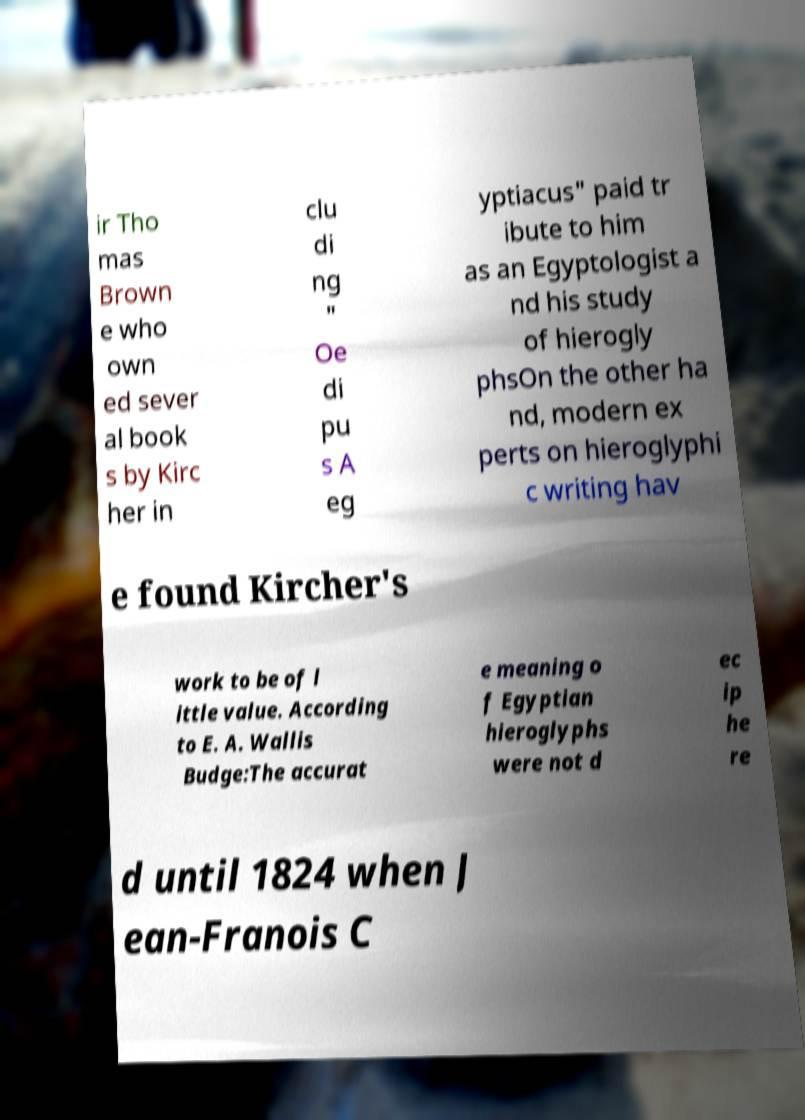Can you read and provide the text displayed in the image?This photo seems to have some interesting text. Can you extract and type it out for me? ir Tho mas Brown e who own ed sever al book s by Kirc her in clu di ng " Oe di pu s A eg yptiacus" paid tr ibute to him as an Egyptologist a nd his study of hierogly phsOn the other ha nd, modern ex perts on hieroglyphi c writing hav e found Kircher's work to be of l ittle value. According to E. A. Wallis Budge:The accurat e meaning o f Egyptian hieroglyphs were not d ec ip he re d until 1824 when J ean-Franois C 